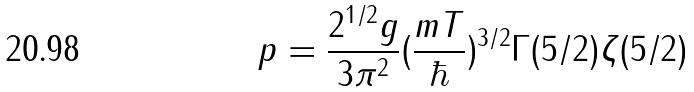<formula> <loc_0><loc_0><loc_500><loc_500>p = \frac { 2 ^ { 1 / 2 } g } { 3 \pi ^ { 2 } } ( \frac { m T } \hbar { ) } ^ { 3 / 2 } \Gamma ( 5 / 2 ) \zeta ( 5 / 2 )</formula> 